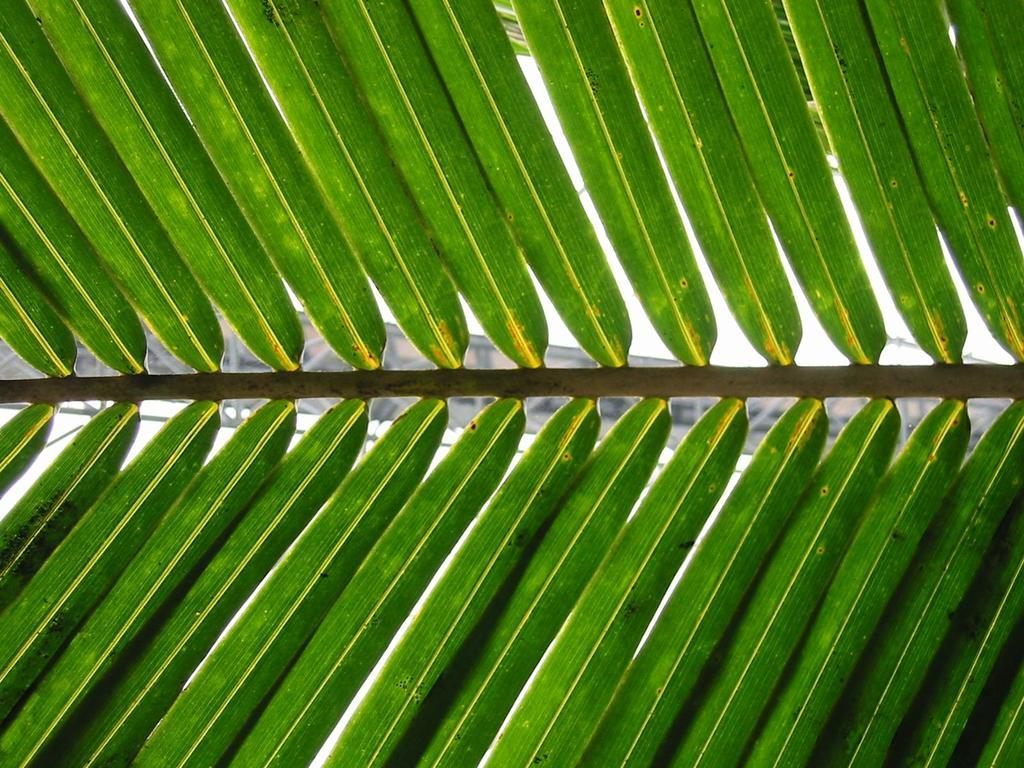What is the main subject of the image? The main subject of the image is a stem of a tree. What can be observed about the tree's leaves? The tree has green color leaves. What is the color of the background in the image? The background of the image is white in color. How many whips are being used by the team in the image? There are no whips or teams present in the image; it features a stem of a tree with green leaves against a white background. 